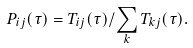Convert formula to latex. <formula><loc_0><loc_0><loc_500><loc_500>P _ { i j } ( \tau ) = T _ { i j } ( \tau ) / \sum _ { k } T _ { k j } ( \tau ) .</formula> 